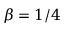Convert formula to latex. <formula><loc_0><loc_0><loc_500><loc_500>\beta = 1 / 4</formula> 